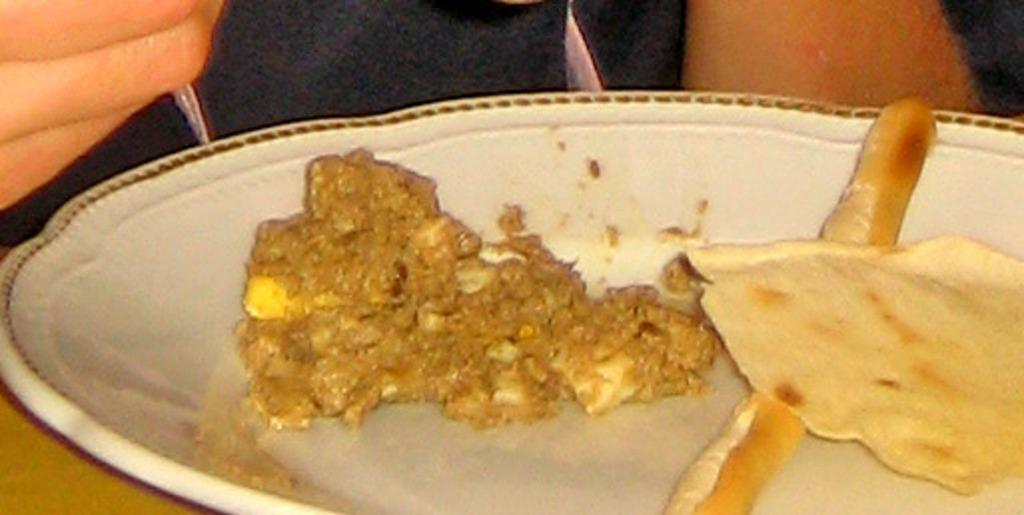What is on the plate that is visible in the image? There is food in a plate in the image. Where is the plate located in the image? The plate is on a wooden table. Can you describe the person in the image? Unfortunately, the facts provided do not give any information about the person in the image. What type of engine is being repaired by the cow in the image? There is no cow or engine present in the image. 